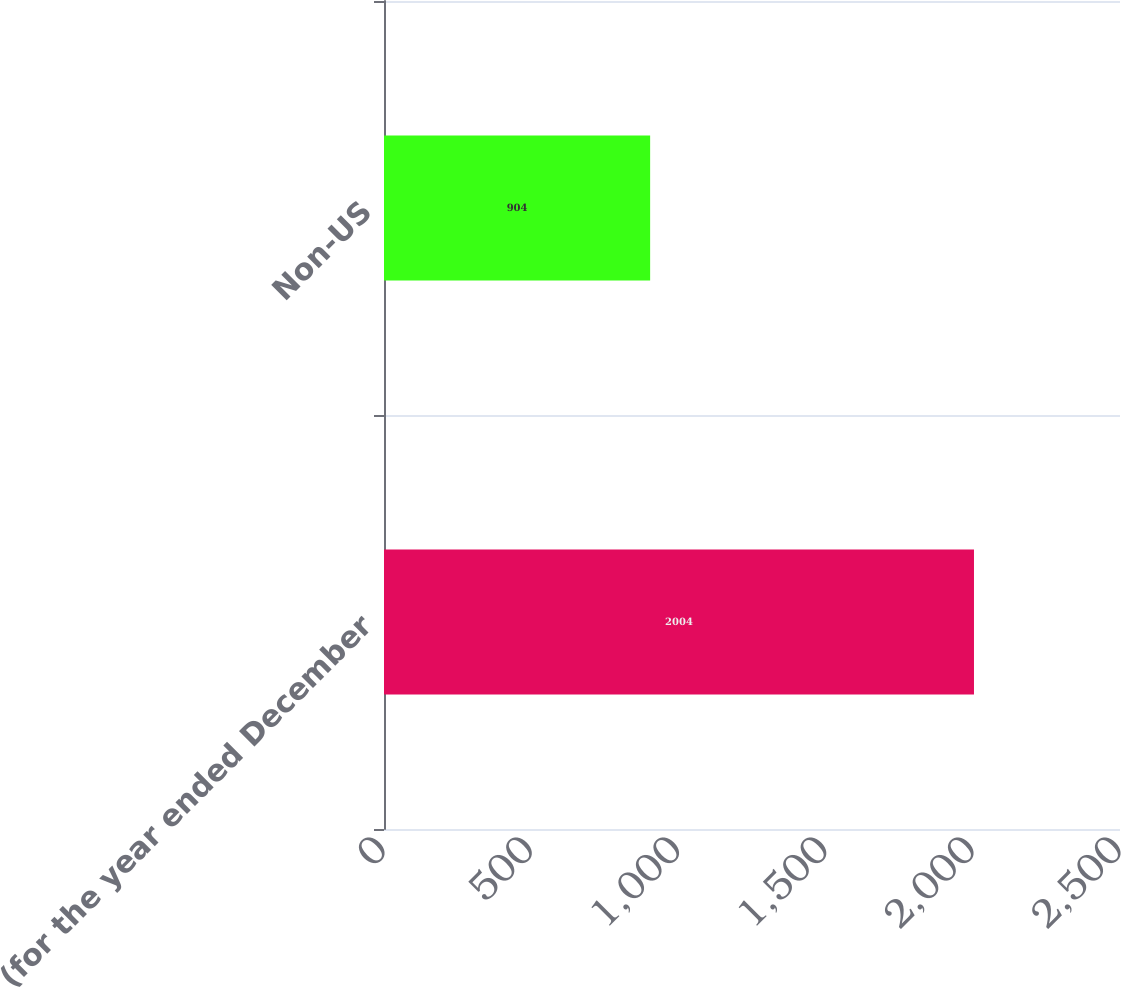Convert chart. <chart><loc_0><loc_0><loc_500><loc_500><bar_chart><fcel>(for the year ended December<fcel>Non-US<nl><fcel>2004<fcel>904<nl></chart> 